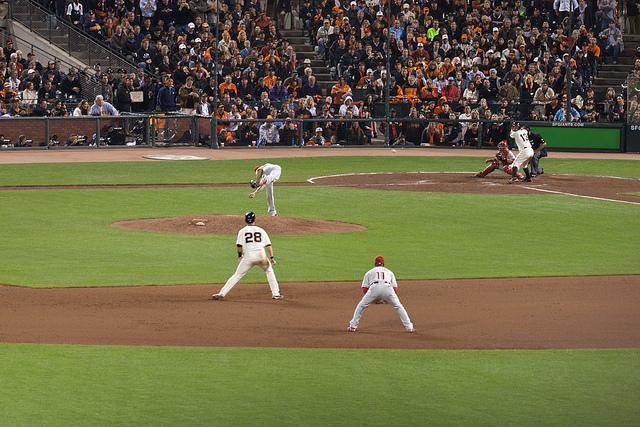How many umpires are there?
Give a very brief answer. 1. How many people are visible?
Give a very brief answer. 3. How many giraffes are there?
Give a very brief answer. 0. 